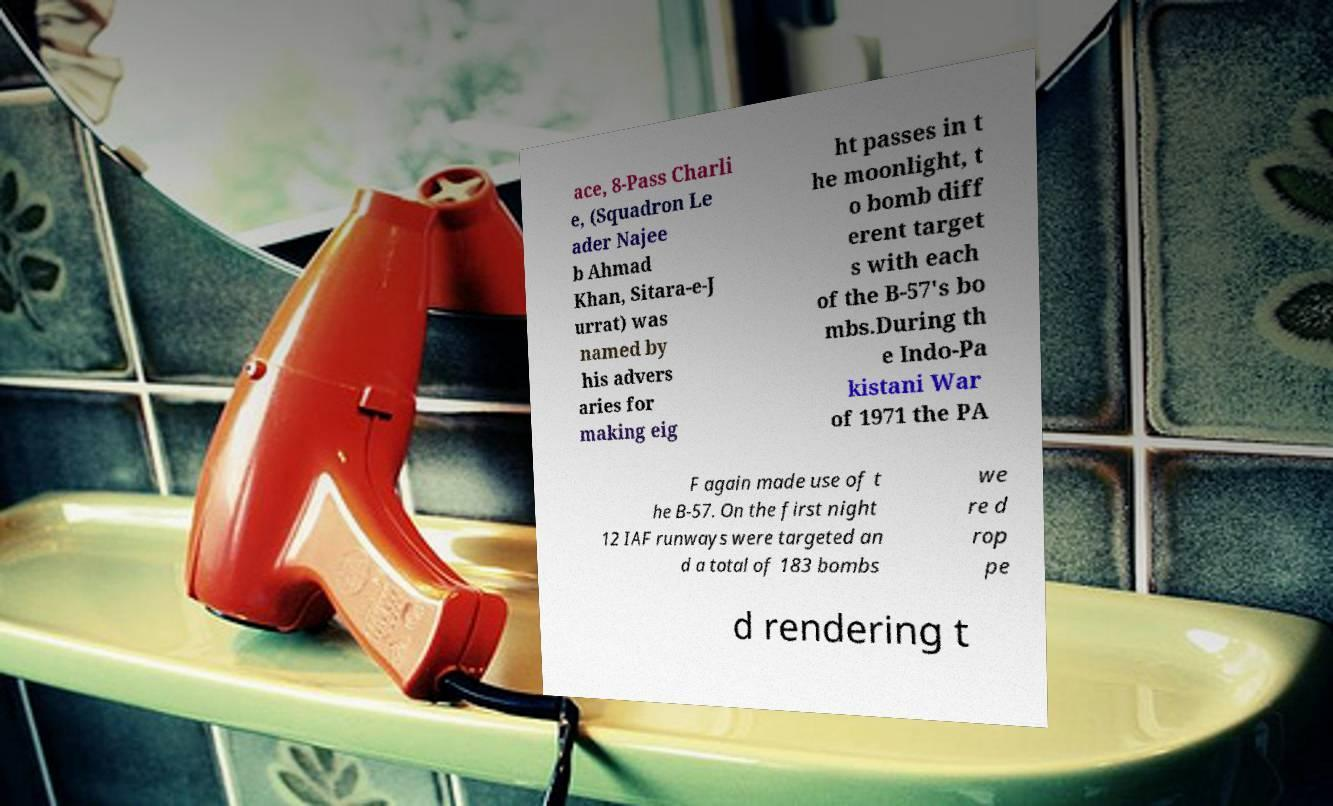Can you accurately transcribe the text from the provided image for me? ace, 8-Pass Charli e, (Squadron Le ader Najee b Ahmad Khan, Sitara-e-J urrat) was named by his advers aries for making eig ht passes in t he moonlight, t o bomb diff erent target s with each of the B-57's bo mbs.During th e Indo-Pa kistani War of 1971 the PA F again made use of t he B-57. On the first night 12 IAF runways were targeted an d a total of 183 bombs we re d rop pe d rendering t 